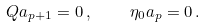Convert formula to latex. <formula><loc_0><loc_0><loc_500><loc_500>Q \L a _ { p + 1 } = 0 \, , \quad \eta _ { 0 } \L a _ { p } = 0 \, .</formula> 